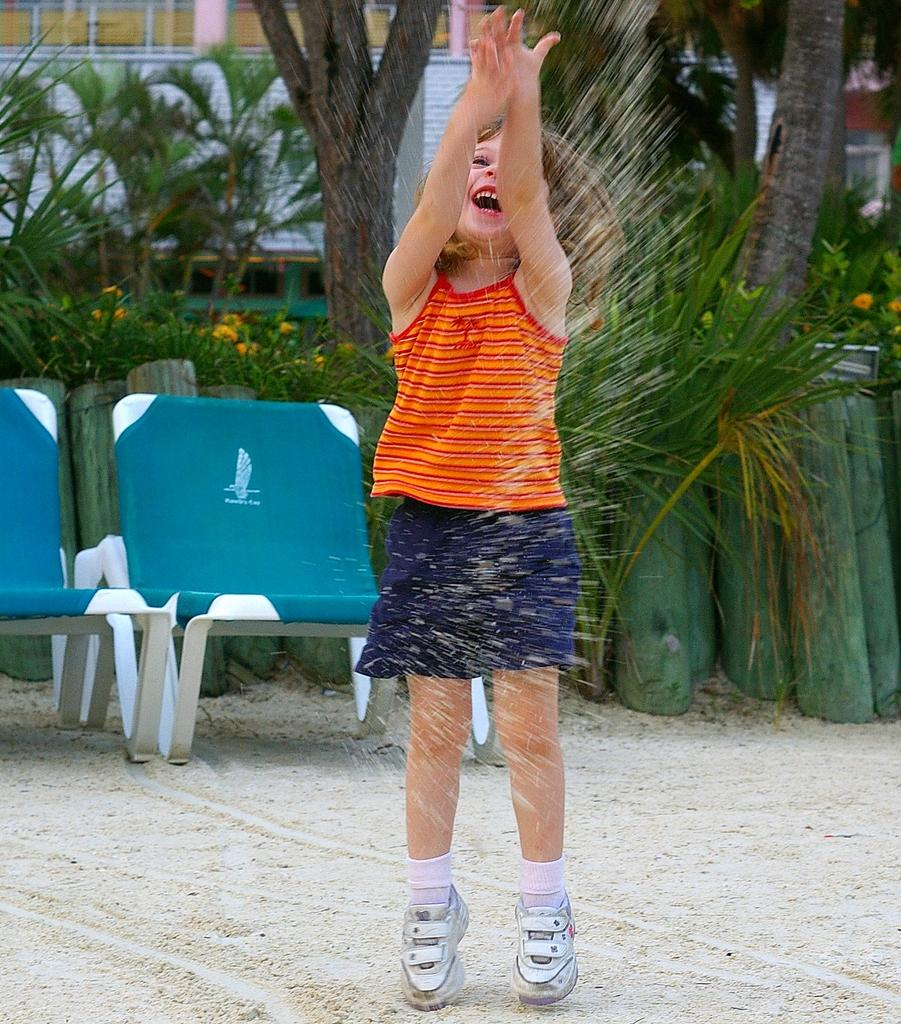Who is the main subject in the picture? There is a girl in the picture. What is the girl doing in the image? The girl is playing with sand. What is the girl wearing in the image? The girl is wearing a blue and orange dress. How many chairs are visible in the image? There are two chairs in the image. What can be seen in the background of the image? Trees and plants are visible in the background. How many bananas are the girl and her team eating in the image? There are no bananas or a team present in the image; the girl is playing with sand and wearing a blue and orange dress. 